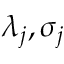<formula> <loc_0><loc_0><loc_500><loc_500>\lambda _ { j } , \sigma _ { j }</formula> 